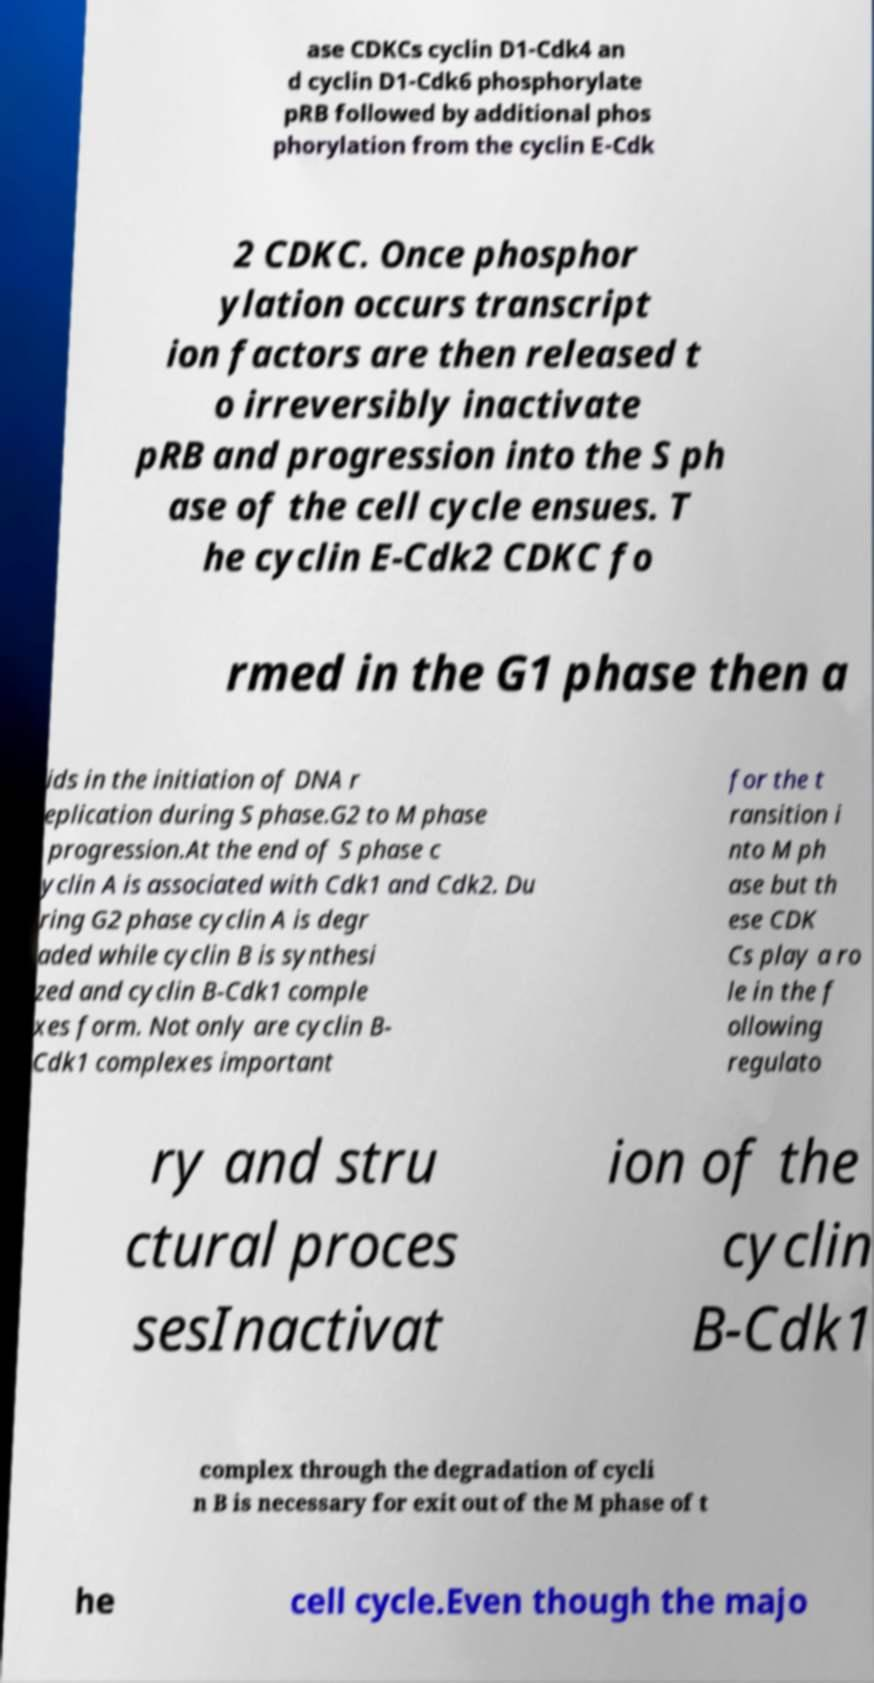Could you assist in decoding the text presented in this image and type it out clearly? ase CDKCs cyclin D1-Cdk4 an d cyclin D1-Cdk6 phosphorylate pRB followed by additional phos phorylation from the cyclin E-Cdk 2 CDKC. Once phosphor ylation occurs transcript ion factors are then released t o irreversibly inactivate pRB and progression into the S ph ase of the cell cycle ensues. T he cyclin E-Cdk2 CDKC fo rmed in the G1 phase then a ids in the initiation of DNA r eplication during S phase.G2 to M phase progression.At the end of S phase c yclin A is associated with Cdk1 and Cdk2. Du ring G2 phase cyclin A is degr aded while cyclin B is synthesi zed and cyclin B-Cdk1 comple xes form. Not only are cyclin B- Cdk1 complexes important for the t ransition i nto M ph ase but th ese CDK Cs play a ro le in the f ollowing regulato ry and stru ctural proces sesInactivat ion of the cyclin B-Cdk1 complex through the degradation of cycli n B is necessary for exit out of the M phase of t he cell cycle.Even though the majo 